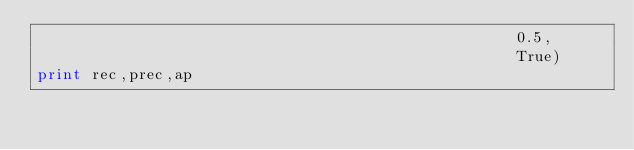<code> <loc_0><loc_0><loc_500><loc_500><_Python_>													0.5,
													True)
print rec,prec,ap
</code> 